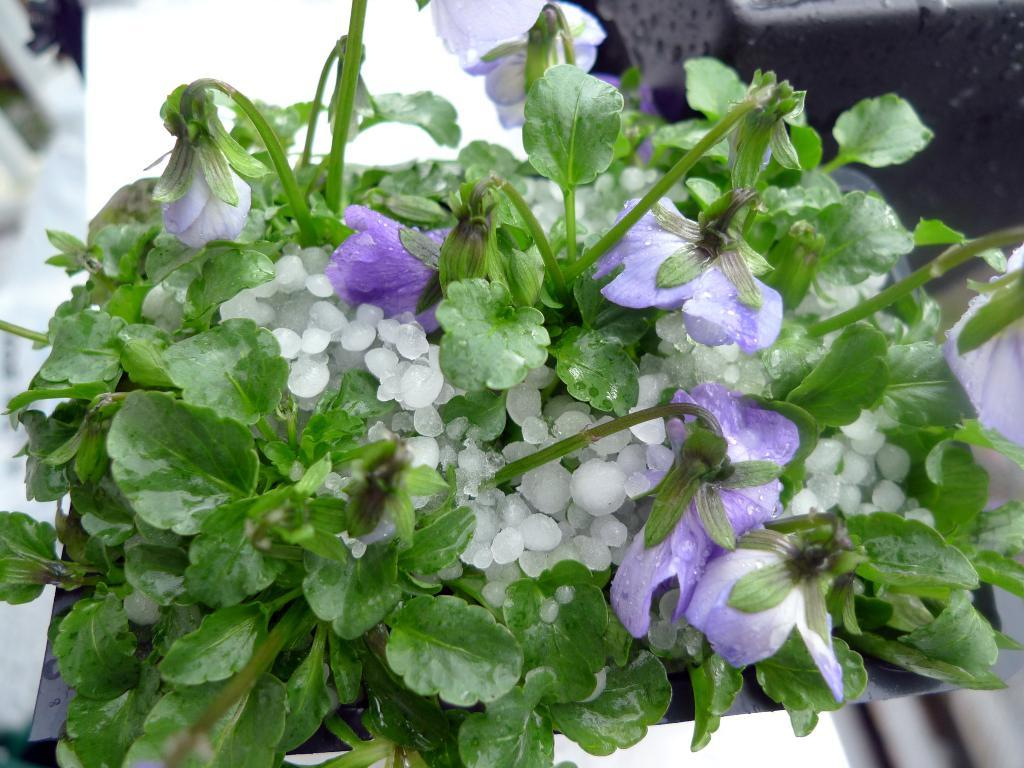What color are the flowers in the image? The flowers in the image are violet in color. What type of plant do the flowers belong to? The flowers belong to a plant, but the specific type of plant is not mentioned in the facts. What other color can be seen in the image? There are white color objects in the image. How would you describe the background of the image? The background of the image is blurred. What type of shape is the police car in the image? There is no police car present in the image, so it is not possible to answer the question about its shape. 